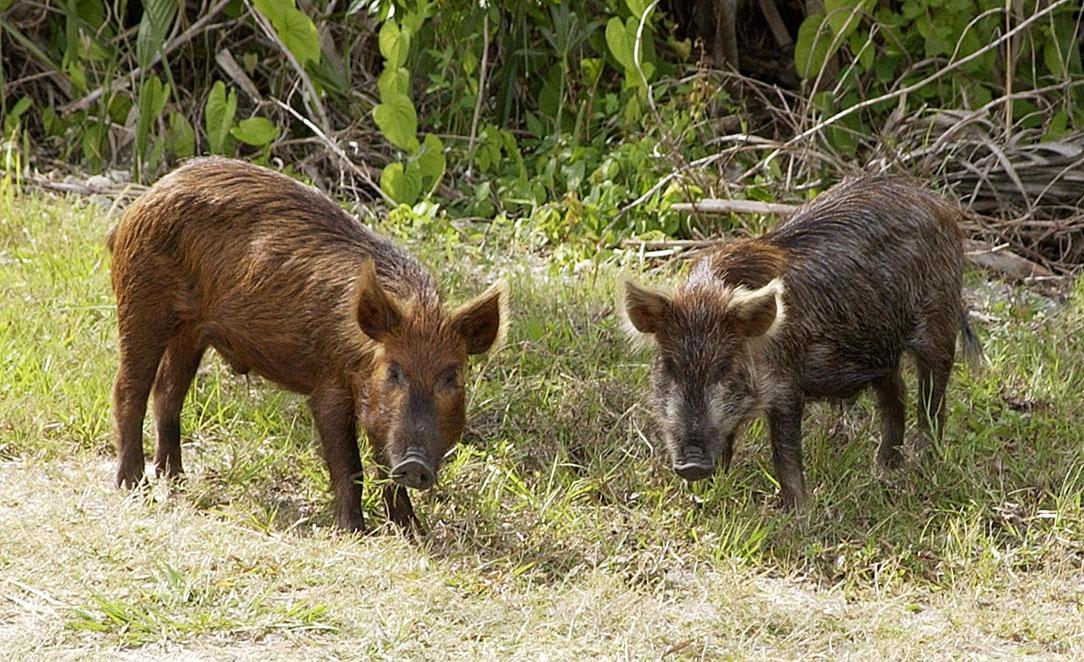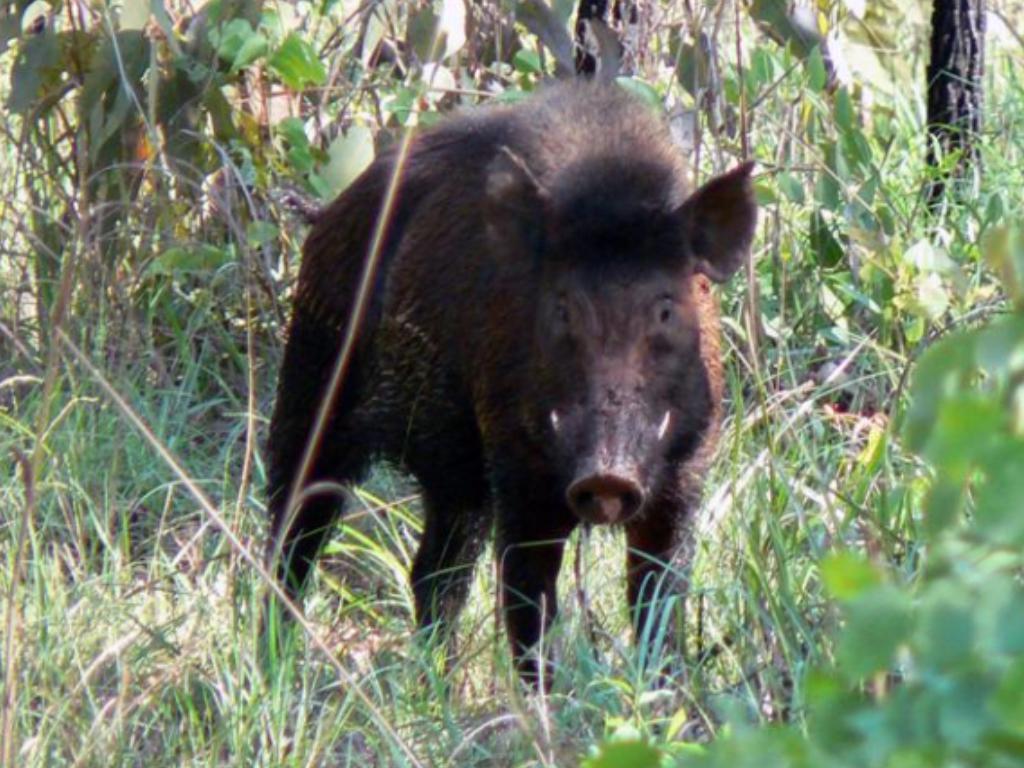The first image is the image on the left, the second image is the image on the right. Considering the images on both sides, is "There are at least two boars in the left image." valid? Answer yes or no. Yes. The first image is the image on the left, the second image is the image on the right. Examine the images to the left and right. Is the description "An image shows one boar standing over the dead body of a hooved animal." accurate? Answer yes or no. No. 